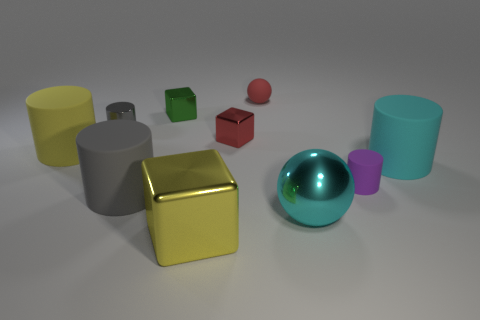Subtract all purple cylinders. How many cylinders are left? 4 Subtract all red cubes. How many gray cylinders are left? 2 Subtract 1 cubes. How many cubes are left? 2 Subtract all gray cylinders. How many cylinders are left? 3 Subtract all spheres. How many objects are left? 8 Subtract all large matte cylinders. Subtract all red matte balls. How many objects are left? 6 Add 6 cyan shiny spheres. How many cyan shiny spheres are left? 7 Add 7 big shiny balls. How many big shiny balls exist? 8 Subtract 0 blue cylinders. How many objects are left? 10 Subtract all red cylinders. Subtract all brown blocks. How many cylinders are left? 5 